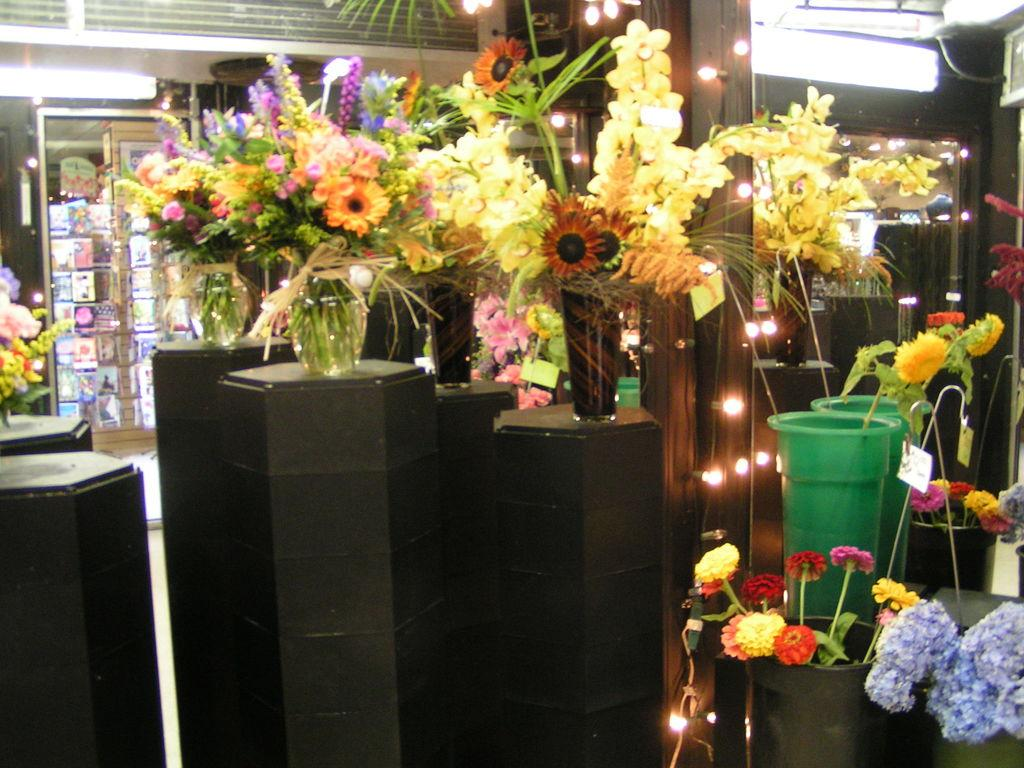What can be found in the flower pots in the image? There are flowers in the flower pots in the image. What can be seen illuminating the area in the image? There are lights visible in the image. What type of structure is present in the image? There are walls in the image. What type of appliance is present in the image? There is a glass door fridge in the image. Are there any ants crawling on the flowers in the image? There is no indication of ants in the image; it only shows flowers in flower pots. Is anyone wearing a mask in the image? There is no person present in the image, so it is not possible to determine if anyone is wearing a mask. 